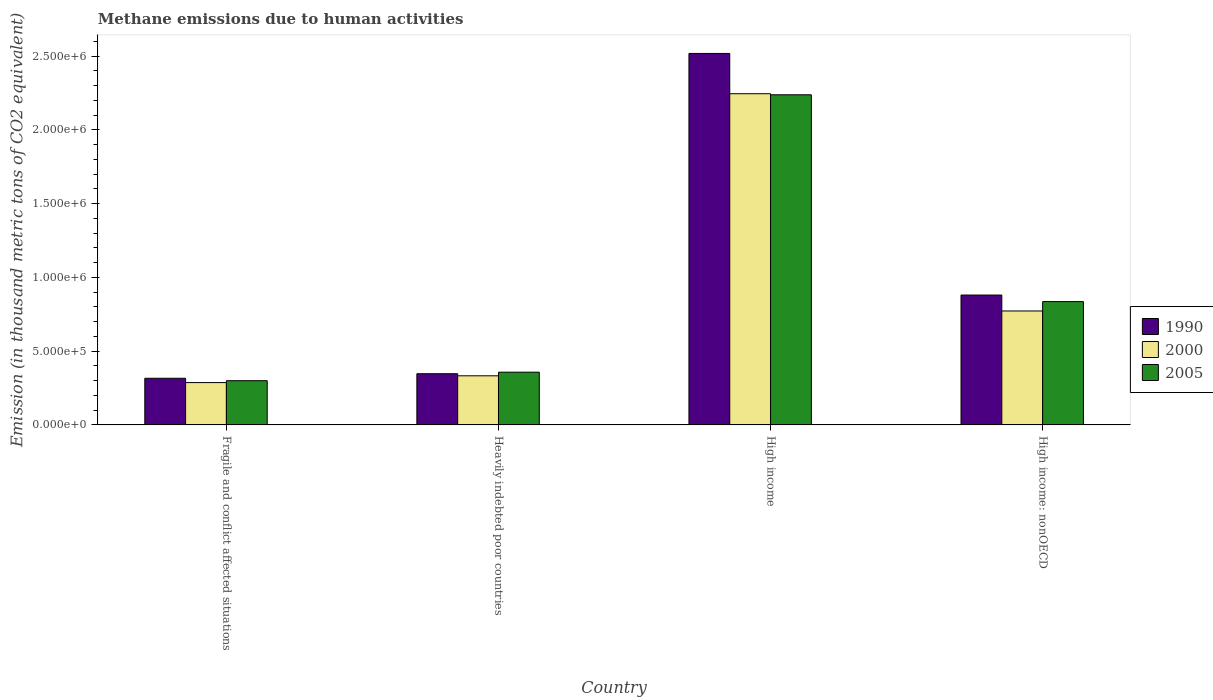How many different coloured bars are there?
Give a very brief answer. 3. How many groups of bars are there?
Your answer should be compact. 4. Are the number of bars on each tick of the X-axis equal?
Ensure brevity in your answer.  Yes. What is the label of the 1st group of bars from the left?
Offer a very short reply. Fragile and conflict affected situations. What is the amount of methane emitted in 1990 in Heavily indebted poor countries?
Your answer should be very brief. 3.47e+05. Across all countries, what is the maximum amount of methane emitted in 1990?
Provide a succinct answer. 2.52e+06. Across all countries, what is the minimum amount of methane emitted in 2005?
Provide a short and direct response. 3.00e+05. In which country was the amount of methane emitted in 2005 minimum?
Ensure brevity in your answer.  Fragile and conflict affected situations. What is the total amount of methane emitted in 2000 in the graph?
Your answer should be compact. 3.64e+06. What is the difference between the amount of methane emitted in 2000 in Fragile and conflict affected situations and that in Heavily indebted poor countries?
Offer a terse response. -4.60e+04. What is the difference between the amount of methane emitted in 1990 in Heavily indebted poor countries and the amount of methane emitted in 2000 in High income?
Offer a very short reply. -1.90e+06. What is the average amount of methane emitted in 1990 per country?
Offer a very short reply. 1.02e+06. What is the difference between the amount of methane emitted of/in 2005 and amount of methane emitted of/in 1990 in Fragile and conflict affected situations?
Your response must be concise. -1.64e+04. What is the ratio of the amount of methane emitted in 2000 in Fragile and conflict affected situations to that in High income: nonOECD?
Provide a succinct answer. 0.37. What is the difference between the highest and the second highest amount of methane emitted in 2000?
Ensure brevity in your answer.  4.39e+05. What is the difference between the highest and the lowest amount of methane emitted in 2005?
Keep it short and to the point. 1.94e+06. In how many countries, is the amount of methane emitted in 2005 greater than the average amount of methane emitted in 2005 taken over all countries?
Make the answer very short. 1. Is the sum of the amount of methane emitted in 2005 in Heavily indebted poor countries and High income: nonOECD greater than the maximum amount of methane emitted in 1990 across all countries?
Your answer should be very brief. No. What does the 3rd bar from the right in High income represents?
Keep it short and to the point. 1990. Is it the case that in every country, the sum of the amount of methane emitted in 2005 and amount of methane emitted in 1990 is greater than the amount of methane emitted in 2000?
Your answer should be very brief. Yes. How many countries are there in the graph?
Ensure brevity in your answer.  4. What is the difference between two consecutive major ticks on the Y-axis?
Ensure brevity in your answer.  5.00e+05. Does the graph contain any zero values?
Keep it short and to the point. No. Does the graph contain grids?
Offer a very short reply. No. How are the legend labels stacked?
Your answer should be very brief. Vertical. What is the title of the graph?
Provide a short and direct response. Methane emissions due to human activities. What is the label or title of the Y-axis?
Your answer should be compact. Emission (in thousand metric tons of CO2 equivalent). What is the Emission (in thousand metric tons of CO2 equivalent) in 1990 in Fragile and conflict affected situations?
Provide a short and direct response. 3.16e+05. What is the Emission (in thousand metric tons of CO2 equivalent) of 2000 in Fragile and conflict affected situations?
Provide a short and direct response. 2.87e+05. What is the Emission (in thousand metric tons of CO2 equivalent) in 2005 in Fragile and conflict affected situations?
Offer a terse response. 3.00e+05. What is the Emission (in thousand metric tons of CO2 equivalent) of 1990 in Heavily indebted poor countries?
Offer a terse response. 3.47e+05. What is the Emission (in thousand metric tons of CO2 equivalent) in 2000 in Heavily indebted poor countries?
Ensure brevity in your answer.  3.33e+05. What is the Emission (in thousand metric tons of CO2 equivalent) in 2005 in Heavily indebted poor countries?
Keep it short and to the point. 3.57e+05. What is the Emission (in thousand metric tons of CO2 equivalent) of 1990 in High income?
Provide a succinct answer. 2.52e+06. What is the Emission (in thousand metric tons of CO2 equivalent) of 2000 in High income?
Offer a terse response. 2.24e+06. What is the Emission (in thousand metric tons of CO2 equivalent) in 2005 in High income?
Make the answer very short. 2.24e+06. What is the Emission (in thousand metric tons of CO2 equivalent) in 1990 in High income: nonOECD?
Your response must be concise. 8.80e+05. What is the Emission (in thousand metric tons of CO2 equivalent) of 2000 in High income: nonOECD?
Your answer should be compact. 7.72e+05. What is the Emission (in thousand metric tons of CO2 equivalent) in 2005 in High income: nonOECD?
Offer a terse response. 8.36e+05. Across all countries, what is the maximum Emission (in thousand metric tons of CO2 equivalent) in 1990?
Make the answer very short. 2.52e+06. Across all countries, what is the maximum Emission (in thousand metric tons of CO2 equivalent) in 2000?
Keep it short and to the point. 2.24e+06. Across all countries, what is the maximum Emission (in thousand metric tons of CO2 equivalent) of 2005?
Provide a short and direct response. 2.24e+06. Across all countries, what is the minimum Emission (in thousand metric tons of CO2 equivalent) of 1990?
Your answer should be very brief. 3.16e+05. Across all countries, what is the minimum Emission (in thousand metric tons of CO2 equivalent) of 2000?
Your response must be concise. 2.87e+05. Across all countries, what is the minimum Emission (in thousand metric tons of CO2 equivalent) in 2005?
Your response must be concise. 3.00e+05. What is the total Emission (in thousand metric tons of CO2 equivalent) of 1990 in the graph?
Make the answer very short. 4.06e+06. What is the total Emission (in thousand metric tons of CO2 equivalent) of 2000 in the graph?
Offer a very short reply. 3.64e+06. What is the total Emission (in thousand metric tons of CO2 equivalent) of 2005 in the graph?
Keep it short and to the point. 3.73e+06. What is the difference between the Emission (in thousand metric tons of CO2 equivalent) in 1990 in Fragile and conflict affected situations and that in Heavily indebted poor countries?
Your answer should be very brief. -3.09e+04. What is the difference between the Emission (in thousand metric tons of CO2 equivalent) of 2000 in Fragile and conflict affected situations and that in Heavily indebted poor countries?
Provide a short and direct response. -4.60e+04. What is the difference between the Emission (in thousand metric tons of CO2 equivalent) in 2005 in Fragile and conflict affected situations and that in Heavily indebted poor countries?
Ensure brevity in your answer.  -5.78e+04. What is the difference between the Emission (in thousand metric tons of CO2 equivalent) of 1990 in Fragile and conflict affected situations and that in High income?
Ensure brevity in your answer.  -2.20e+06. What is the difference between the Emission (in thousand metric tons of CO2 equivalent) of 2000 in Fragile and conflict affected situations and that in High income?
Offer a very short reply. -1.96e+06. What is the difference between the Emission (in thousand metric tons of CO2 equivalent) of 2005 in Fragile and conflict affected situations and that in High income?
Offer a very short reply. -1.94e+06. What is the difference between the Emission (in thousand metric tons of CO2 equivalent) in 1990 in Fragile and conflict affected situations and that in High income: nonOECD?
Your answer should be compact. -5.64e+05. What is the difference between the Emission (in thousand metric tons of CO2 equivalent) in 2000 in Fragile and conflict affected situations and that in High income: nonOECD?
Your answer should be very brief. -4.85e+05. What is the difference between the Emission (in thousand metric tons of CO2 equivalent) of 2005 in Fragile and conflict affected situations and that in High income: nonOECD?
Offer a very short reply. -5.36e+05. What is the difference between the Emission (in thousand metric tons of CO2 equivalent) in 1990 in Heavily indebted poor countries and that in High income?
Offer a very short reply. -2.17e+06. What is the difference between the Emission (in thousand metric tons of CO2 equivalent) of 2000 in Heavily indebted poor countries and that in High income?
Your response must be concise. -1.91e+06. What is the difference between the Emission (in thousand metric tons of CO2 equivalent) in 2005 in Heavily indebted poor countries and that in High income?
Give a very brief answer. -1.88e+06. What is the difference between the Emission (in thousand metric tons of CO2 equivalent) in 1990 in Heavily indebted poor countries and that in High income: nonOECD?
Provide a short and direct response. -5.33e+05. What is the difference between the Emission (in thousand metric tons of CO2 equivalent) of 2000 in Heavily indebted poor countries and that in High income: nonOECD?
Provide a short and direct response. -4.39e+05. What is the difference between the Emission (in thousand metric tons of CO2 equivalent) in 2005 in Heavily indebted poor countries and that in High income: nonOECD?
Provide a succinct answer. -4.78e+05. What is the difference between the Emission (in thousand metric tons of CO2 equivalent) in 1990 in High income and that in High income: nonOECD?
Offer a terse response. 1.64e+06. What is the difference between the Emission (in thousand metric tons of CO2 equivalent) in 2000 in High income and that in High income: nonOECD?
Provide a short and direct response. 1.47e+06. What is the difference between the Emission (in thousand metric tons of CO2 equivalent) in 2005 in High income and that in High income: nonOECD?
Keep it short and to the point. 1.40e+06. What is the difference between the Emission (in thousand metric tons of CO2 equivalent) of 1990 in Fragile and conflict affected situations and the Emission (in thousand metric tons of CO2 equivalent) of 2000 in Heavily indebted poor countries?
Your answer should be very brief. -1.68e+04. What is the difference between the Emission (in thousand metric tons of CO2 equivalent) of 1990 in Fragile and conflict affected situations and the Emission (in thousand metric tons of CO2 equivalent) of 2005 in Heavily indebted poor countries?
Keep it short and to the point. -4.14e+04. What is the difference between the Emission (in thousand metric tons of CO2 equivalent) of 2000 in Fragile and conflict affected situations and the Emission (in thousand metric tons of CO2 equivalent) of 2005 in Heavily indebted poor countries?
Your answer should be very brief. -7.06e+04. What is the difference between the Emission (in thousand metric tons of CO2 equivalent) in 1990 in Fragile and conflict affected situations and the Emission (in thousand metric tons of CO2 equivalent) in 2000 in High income?
Provide a short and direct response. -1.93e+06. What is the difference between the Emission (in thousand metric tons of CO2 equivalent) in 1990 in Fragile and conflict affected situations and the Emission (in thousand metric tons of CO2 equivalent) in 2005 in High income?
Your answer should be compact. -1.92e+06. What is the difference between the Emission (in thousand metric tons of CO2 equivalent) of 2000 in Fragile and conflict affected situations and the Emission (in thousand metric tons of CO2 equivalent) of 2005 in High income?
Keep it short and to the point. -1.95e+06. What is the difference between the Emission (in thousand metric tons of CO2 equivalent) in 1990 in Fragile and conflict affected situations and the Emission (in thousand metric tons of CO2 equivalent) in 2000 in High income: nonOECD?
Your answer should be compact. -4.56e+05. What is the difference between the Emission (in thousand metric tons of CO2 equivalent) of 1990 in Fragile and conflict affected situations and the Emission (in thousand metric tons of CO2 equivalent) of 2005 in High income: nonOECD?
Your response must be concise. -5.20e+05. What is the difference between the Emission (in thousand metric tons of CO2 equivalent) in 2000 in Fragile and conflict affected situations and the Emission (in thousand metric tons of CO2 equivalent) in 2005 in High income: nonOECD?
Make the answer very short. -5.49e+05. What is the difference between the Emission (in thousand metric tons of CO2 equivalent) of 1990 in Heavily indebted poor countries and the Emission (in thousand metric tons of CO2 equivalent) of 2000 in High income?
Ensure brevity in your answer.  -1.90e+06. What is the difference between the Emission (in thousand metric tons of CO2 equivalent) in 1990 in Heavily indebted poor countries and the Emission (in thousand metric tons of CO2 equivalent) in 2005 in High income?
Provide a succinct answer. -1.89e+06. What is the difference between the Emission (in thousand metric tons of CO2 equivalent) of 2000 in Heavily indebted poor countries and the Emission (in thousand metric tons of CO2 equivalent) of 2005 in High income?
Provide a short and direct response. -1.90e+06. What is the difference between the Emission (in thousand metric tons of CO2 equivalent) in 1990 in Heavily indebted poor countries and the Emission (in thousand metric tons of CO2 equivalent) in 2000 in High income: nonOECD?
Make the answer very short. -4.25e+05. What is the difference between the Emission (in thousand metric tons of CO2 equivalent) of 1990 in Heavily indebted poor countries and the Emission (in thousand metric tons of CO2 equivalent) of 2005 in High income: nonOECD?
Your answer should be compact. -4.89e+05. What is the difference between the Emission (in thousand metric tons of CO2 equivalent) in 2000 in Heavily indebted poor countries and the Emission (in thousand metric tons of CO2 equivalent) in 2005 in High income: nonOECD?
Offer a terse response. -5.03e+05. What is the difference between the Emission (in thousand metric tons of CO2 equivalent) in 1990 in High income and the Emission (in thousand metric tons of CO2 equivalent) in 2000 in High income: nonOECD?
Your answer should be compact. 1.75e+06. What is the difference between the Emission (in thousand metric tons of CO2 equivalent) of 1990 in High income and the Emission (in thousand metric tons of CO2 equivalent) of 2005 in High income: nonOECD?
Your response must be concise. 1.68e+06. What is the difference between the Emission (in thousand metric tons of CO2 equivalent) in 2000 in High income and the Emission (in thousand metric tons of CO2 equivalent) in 2005 in High income: nonOECD?
Your answer should be compact. 1.41e+06. What is the average Emission (in thousand metric tons of CO2 equivalent) in 1990 per country?
Make the answer very short. 1.02e+06. What is the average Emission (in thousand metric tons of CO2 equivalent) in 2000 per country?
Provide a succinct answer. 9.09e+05. What is the average Emission (in thousand metric tons of CO2 equivalent) in 2005 per country?
Your answer should be compact. 9.32e+05. What is the difference between the Emission (in thousand metric tons of CO2 equivalent) of 1990 and Emission (in thousand metric tons of CO2 equivalent) of 2000 in Fragile and conflict affected situations?
Your answer should be compact. 2.92e+04. What is the difference between the Emission (in thousand metric tons of CO2 equivalent) of 1990 and Emission (in thousand metric tons of CO2 equivalent) of 2005 in Fragile and conflict affected situations?
Your answer should be compact. 1.64e+04. What is the difference between the Emission (in thousand metric tons of CO2 equivalent) of 2000 and Emission (in thousand metric tons of CO2 equivalent) of 2005 in Fragile and conflict affected situations?
Your answer should be very brief. -1.28e+04. What is the difference between the Emission (in thousand metric tons of CO2 equivalent) in 1990 and Emission (in thousand metric tons of CO2 equivalent) in 2000 in Heavily indebted poor countries?
Your answer should be very brief. 1.41e+04. What is the difference between the Emission (in thousand metric tons of CO2 equivalent) in 1990 and Emission (in thousand metric tons of CO2 equivalent) in 2005 in Heavily indebted poor countries?
Provide a succinct answer. -1.05e+04. What is the difference between the Emission (in thousand metric tons of CO2 equivalent) in 2000 and Emission (in thousand metric tons of CO2 equivalent) in 2005 in Heavily indebted poor countries?
Offer a terse response. -2.46e+04. What is the difference between the Emission (in thousand metric tons of CO2 equivalent) of 1990 and Emission (in thousand metric tons of CO2 equivalent) of 2000 in High income?
Make the answer very short. 2.73e+05. What is the difference between the Emission (in thousand metric tons of CO2 equivalent) of 1990 and Emission (in thousand metric tons of CO2 equivalent) of 2005 in High income?
Offer a terse response. 2.80e+05. What is the difference between the Emission (in thousand metric tons of CO2 equivalent) in 2000 and Emission (in thousand metric tons of CO2 equivalent) in 2005 in High income?
Provide a succinct answer. 7311.3. What is the difference between the Emission (in thousand metric tons of CO2 equivalent) in 1990 and Emission (in thousand metric tons of CO2 equivalent) in 2000 in High income: nonOECD?
Make the answer very short. 1.08e+05. What is the difference between the Emission (in thousand metric tons of CO2 equivalent) in 1990 and Emission (in thousand metric tons of CO2 equivalent) in 2005 in High income: nonOECD?
Ensure brevity in your answer.  4.45e+04. What is the difference between the Emission (in thousand metric tons of CO2 equivalent) of 2000 and Emission (in thousand metric tons of CO2 equivalent) of 2005 in High income: nonOECD?
Offer a terse response. -6.35e+04. What is the ratio of the Emission (in thousand metric tons of CO2 equivalent) in 1990 in Fragile and conflict affected situations to that in Heavily indebted poor countries?
Provide a short and direct response. 0.91. What is the ratio of the Emission (in thousand metric tons of CO2 equivalent) in 2000 in Fragile and conflict affected situations to that in Heavily indebted poor countries?
Offer a terse response. 0.86. What is the ratio of the Emission (in thousand metric tons of CO2 equivalent) of 2005 in Fragile and conflict affected situations to that in Heavily indebted poor countries?
Offer a terse response. 0.84. What is the ratio of the Emission (in thousand metric tons of CO2 equivalent) of 1990 in Fragile and conflict affected situations to that in High income?
Make the answer very short. 0.13. What is the ratio of the Emission (in thousand metric tons of CO2 equivalent) in 2000 in Fragile and conflict affected situations to that in High income?
Offer a terse response. 0.13. What is the ratio of the Emission (in thousand metric tons of CO2 equivalent) of 2005 in Fragile and conflict affected situations to that in High income?
Offer a very short reply. 0.13. What is the ratio of the Emission (in thousand metric tons of CO2 equivalent) of 1990 in Fragile and conflict affected situations to that in High income: nonOECD?
Provide a short and direct response. 0.36. What is the ratio of the Emission (in thousand metric tons of CO2 equivalent) of 2000 in Fragile and conflict affected situations to that in High income: nonOECD?
Your answer should be compact. 0.37. What is the ratio of the Emission (in thousand metric tons of CO2 equivalent) of 2005 in Fragile and conflict affected situations to that in High income: nonOECD?
Offer a terse response. 0.36. What is the ratio of the Emission (in thousand metric tons of CO2 equivalent) of 1990 in Heavily indebted poor countries to that in High income?
Your answer should be compact. 0.14. What is the ratio of the Emission (in thousand metric tons of CO2 equivalent) of 2000 in Heavily indebted poor countries to that in High income?
Give a very brief answer. 0.15. What is the ratio of the Emission (in thousand metric tons of CO2 equivalent) in 2005 in Heavily indebted poor countries to that in High income?
Your response must be concise. 0.16. What is the ratio of the Emission (in thousand metric tons of CO2 equivalent) in 1990 in Heavily indebted poor countries to that in High income: nonOECD?
Offer a very short reply. 0.39. What is the ratio of the Emission (in thousand metric tons of CO2 equivalent) in 2000 in Heavily indebted poor countries to that in High income: nonOECD?
Provide a succinct answer. 0.43. What is the ratio of the Emission (in thousand metric tons of CO2 equivalent) of 2005 in Heavily indebted poor countries to that in High income: nonOECD?
Your answer should be very brief. 0.43. What is the ratio of the Emission (in thousand metric tons of CO2 equivalent) of 1990 in High income to that in High income: nonOECD?
Your response must be concise. 2.86. What is the ratio of the Emission (in thousand metric tons of CO2 equivalent) of 2000 in High income to that in High income: nonOECD?
Your response must be concise. 2.91. What is the ratio of the Emission (in thousand metric tons of CO2 equivalent) of 2005 in High income to that in High income: nonOECD?
Make the answer very short. 2.68. What is the difference between the highest and the second highest Emission (in thousand metric tons of CO2 equivalent) of 1990?
Make the answer very short. 1.64e+06. What is the difference between the highest and the second highest Emission (in thousand metric tons of CO2 equivalent) in 2000?
Give a very brief answer. 1.47e+06. What is the difference between the highest and the second highest Emission (in thousand metric tons of CO2 equivalent) of 2005?
Your answer should be compact. 1.40e+06. What is the difference between the highest and the lowest Emission (in thousand metric tons of CO2 equivalent) of 1990?
Ensure brevity in your answer.  2.20e+06. What is the difference between the highest and the lowest Emission (in thousand metric tons of CO2 equivalent) of 2000?
Keep it short and to the point. 1.96e+06. What is the difference between the highest and the lowest Emission (in thousand metric tons of CO2 equivalent) in 2005?
Keep it short and to the point. 1.94e+06. 